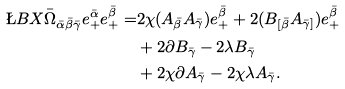Convert formula to latex. <formula><loc_0><loc_0><loc_500><loc_500>\L B { X } { \bar { \Omega } _ { \bar { \alpha } \bar { \beta } \bar { \gamma } } e _ { + } ^ { \bar { \alpha } } e _ { + } ^ { \bar { \beta } } } = & 2 \chi ( A _ { \bar { \beta } } A _ { \bar { \gamma } } ) e _ { + } ^ { \bar { \beta } } + 2 ( B _ { [ \bar { \beta } } A _ { \bar { \gamma } ] } ) e _ { + } ^ { \bar { \beta } } \\ & + 2 \partial B _ { \bar { \gamma } } - 2 \lambda B _ { \bar { \gamma } } \\ & + 2 \chi \partial A _ { \bar { \gamma } } - 2 \chi \lambda A _ { \bar { \gamma } } .</formula> 